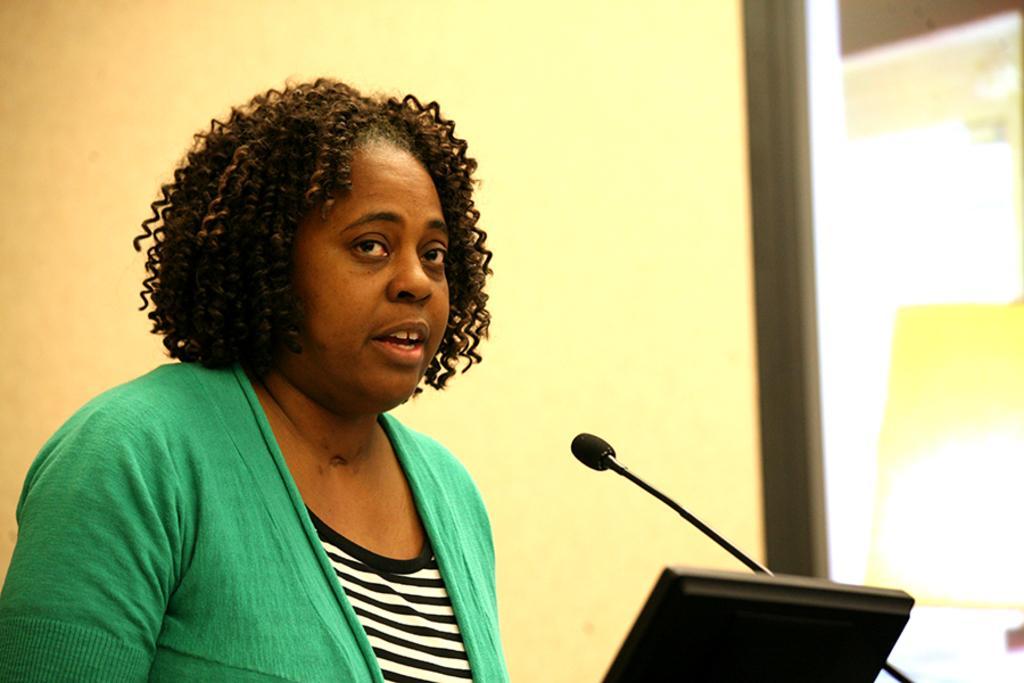Describe this image in one or two sentences. In this picture we can see a woman and in front of her we can see a mic, device and in the background we can see the wall, glass. 